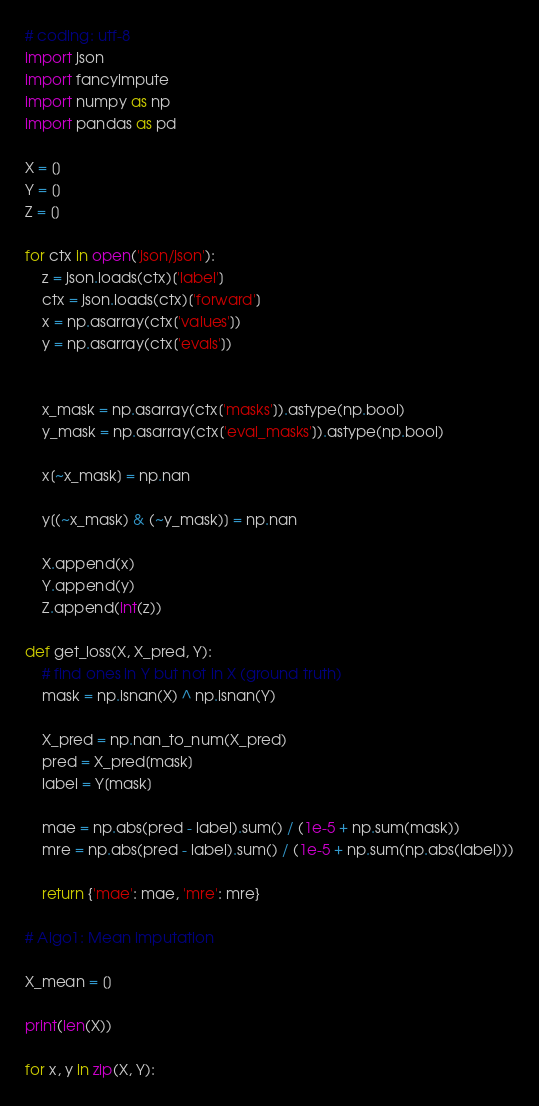Convert code to text. <code><loc_0><loc_0><loc_500><loc_500><_Python_># coding: utf-8
import json
import fancyimpute
import numpy as np
import pandas as pd

X = []
Y = []
Z = []

for ctx in open('json/json'):
    z = json.loads(ctx)['label']
    ctx = json.loads(ctx)['forward']
    x = np.asarray(ctx['values'])
    y = np.asarray(ctx['evals'])


    x_mask = np.asarray(ctx['masks']).astype(np.bool)
    y_mask = np.asarray(ctx['eval_masks']).astype(np.bool)

    x[~x_mask] = np.nan

    y[(~x_mask) & (~y_mask)] = np.nan

    X.append(x)
    Y.append(y)
    Z.append(int(z))

def get_loss(X, X_pred, Y):
    # find ones in Y but not in X (ground truth)
    mask = np.isnan(X) ^ np.isnan(Y)

    X_pred = np.nan_to_num(X_pred)
    pred = X_pred[mask]
    label = Y[mask]

    mae = np.abs(pred - label).sum() / (1e-5 + np.sum(mask))
    mre = np.abs(pred - label).sum() / (1e-5 + np.sum(np.abs(label)))

    return {'mae': mae, 'mre': mre}

# Algo1: Mean imputation

X_mean = []

print(len(X))

for x, y in zip(X, Y):</code> 